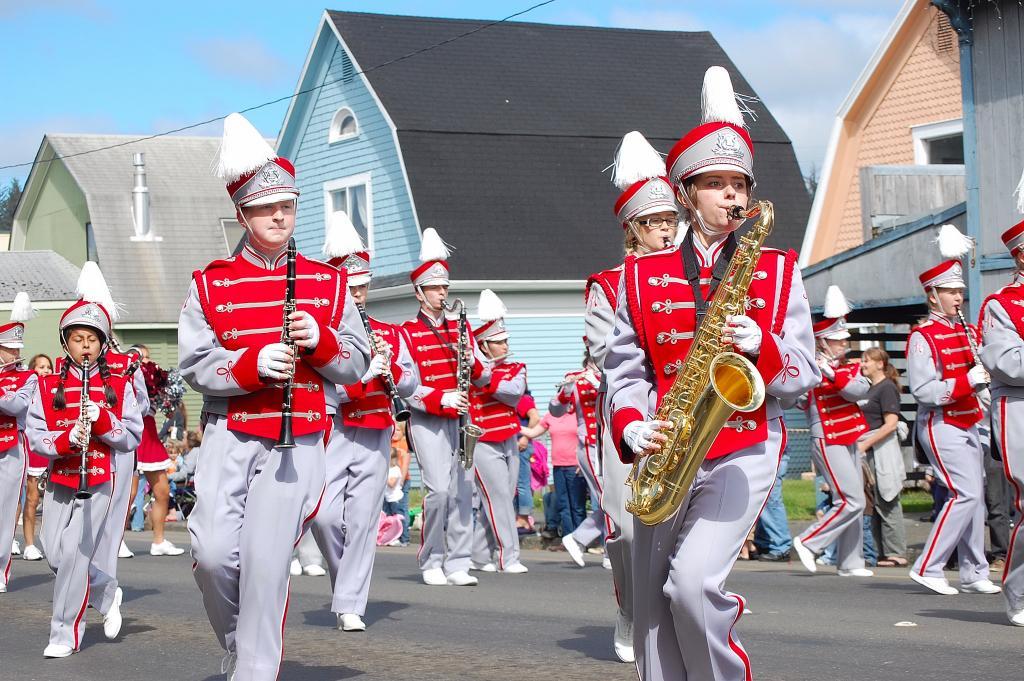In one or two sentences, can you explain what this image depicts? This image is taken outdoors. At the bottom of the image there is a road. In the background there is a ground with grass on it and there are a few houses with walls, windows, doors and roofs. At the top of the image there is a sky with clouds. In the middle of the image there are many people are walking on the ground and playing music with the musical instruments. 